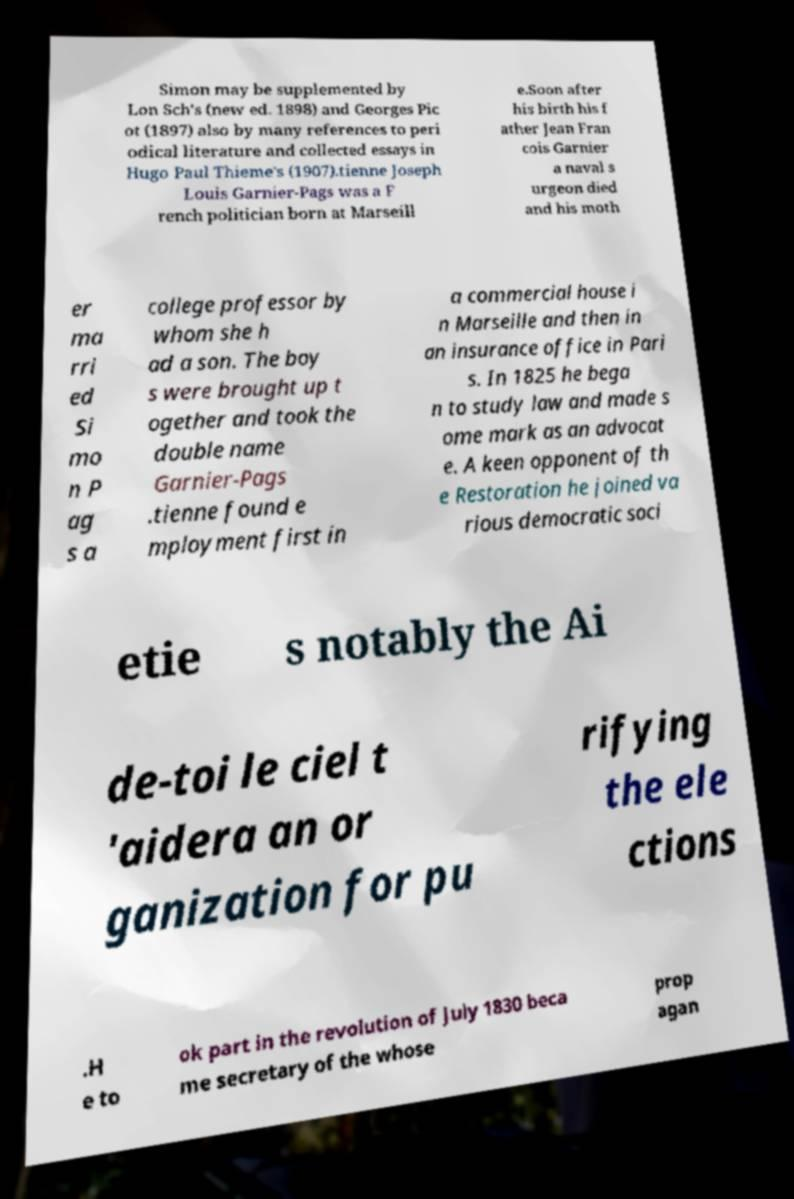I need the written content from this picture converted into text. Can you do that? Simon may be supplemented by Lon Sch's (new ed. 1898) and Georges Pic ot (1897) also by many references to peri odical literature and collected essays in Hugo Paul Thieme's (1907).tienne Joseph Louis Garnier-Pags was a F rench politician born at Marseill e.Soon after his birth his f ather Jean Fran cois Garnier a naval s urgeon died and his moth er ma rri ed Si mo n P ag s a college professor by whom she h ad a son. The boy s were brought up t ogether and took the double name Garnier-Pags .tienne found e mployment first in a commercial house i n Marseille and then in an insurance office in Pari s. In 1825 he bega n to study law and made s ome mark as an advocat e. A keen opponent of th e Restoration he joined va rious democratic soci etie s notably the Ai de-toi le ciel t 'aidera an or ganization for pu rifying the ele ctions .H e to ok part in the revolution of July 1830 beca me secretary of the whose prop agan 